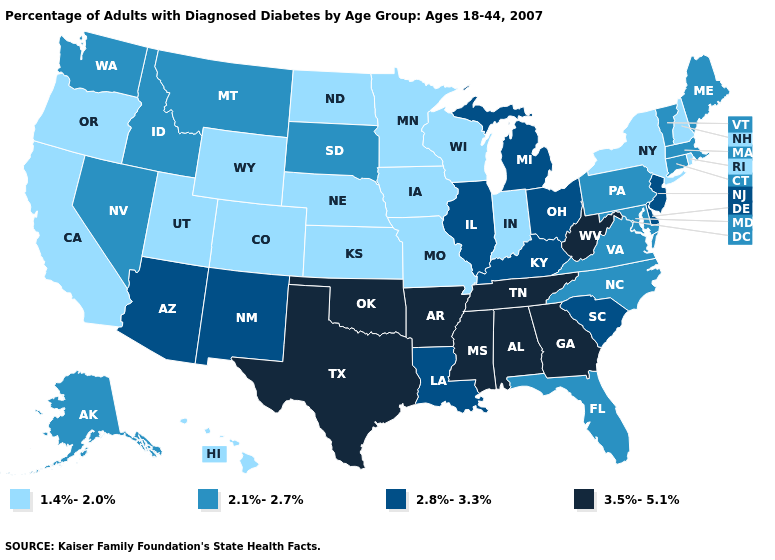What is the value of Georgia?
Keep it brief. 3.5%-5.1%. Does New Jersey have the highest value in the Northeast?
Short answer required. Yes. What is the value of Kentucky?
Give a very brief answer. 2.8%-3.3%. What is the highest value in the Northeast ?
Be succinct. 2.8%-3.3%. Does Ohio have the lowest value in the USA?
Write a very short answer. No. Does New Mexico have a lower value than Texas?
Concise answer only. Yes. What is the value of New York?
Be succinct. 1.4%-2.0%. What is the value of Kentucky?
Write a very short answer. 2.8%-3.3%. Which states have the lowest value in the USA?
Answer briefly. California, Colorado, Hawaii, Indiana, Iowa, Kansas, Minnesota, Missouri, Nebraska, New Hampshire, New York, North Dakota, Oregon, Rhode Island, Utah, Wisconsin, Wyoming. Name the states that have a value in the range 1.4%-2.0%?
Concise answer only. California, Colorado, Hawaii, Indiana, Iowa, Kansas, Minnesota, Missouri, Nebraska, New Hampshire, New York, North Dakota, Oregon, Rhode Island, Utah, Wisconsin, Wyoming. What is the value of Colorado?
Be succinct. 1.4%-2.0%. What is the lowest value in the West?
Answer briefly. 1.4%-2.0%. Name the states that have a value in the range 2.1%-2.7%?
Write a very short answer. Alaska, Connecticut, Florida, Idaho, Maine, Maryland, Massachusetts, Montana, Nevada, North Carolina, Pennsylvania, South Dakota, Vermont, Virginia, Washington. What is the value of Washington?
Concise answer only. 2.1%-2.7%. What is the value of Indiana?
Write a very short answer. 1.4%-2.0%. 